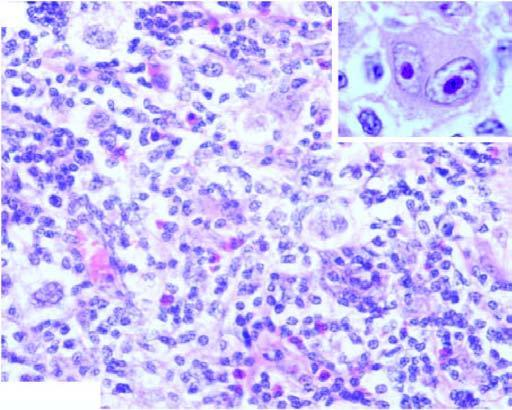re there bands of collagen forming nodules and characteristic lacunar rs cells?
Answer the question using a single word or phrase. Yes 